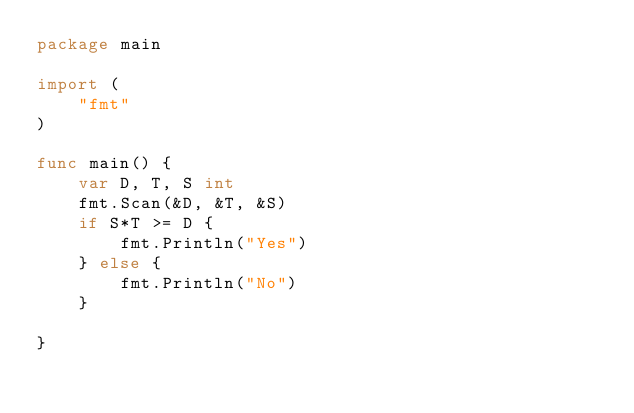Convert code to text. <code><loc_0><loc_0><loc_500><loc_500><_Go_>package main

import (
	"fmt"
)

func main() {
	var D, T, S int
	fmt.Scan(&D, &T, &S)
	if S*T >= D {
		fmt.Println("Yes")
	} else {
		fmt.Println("No")
	}

}
</code> 